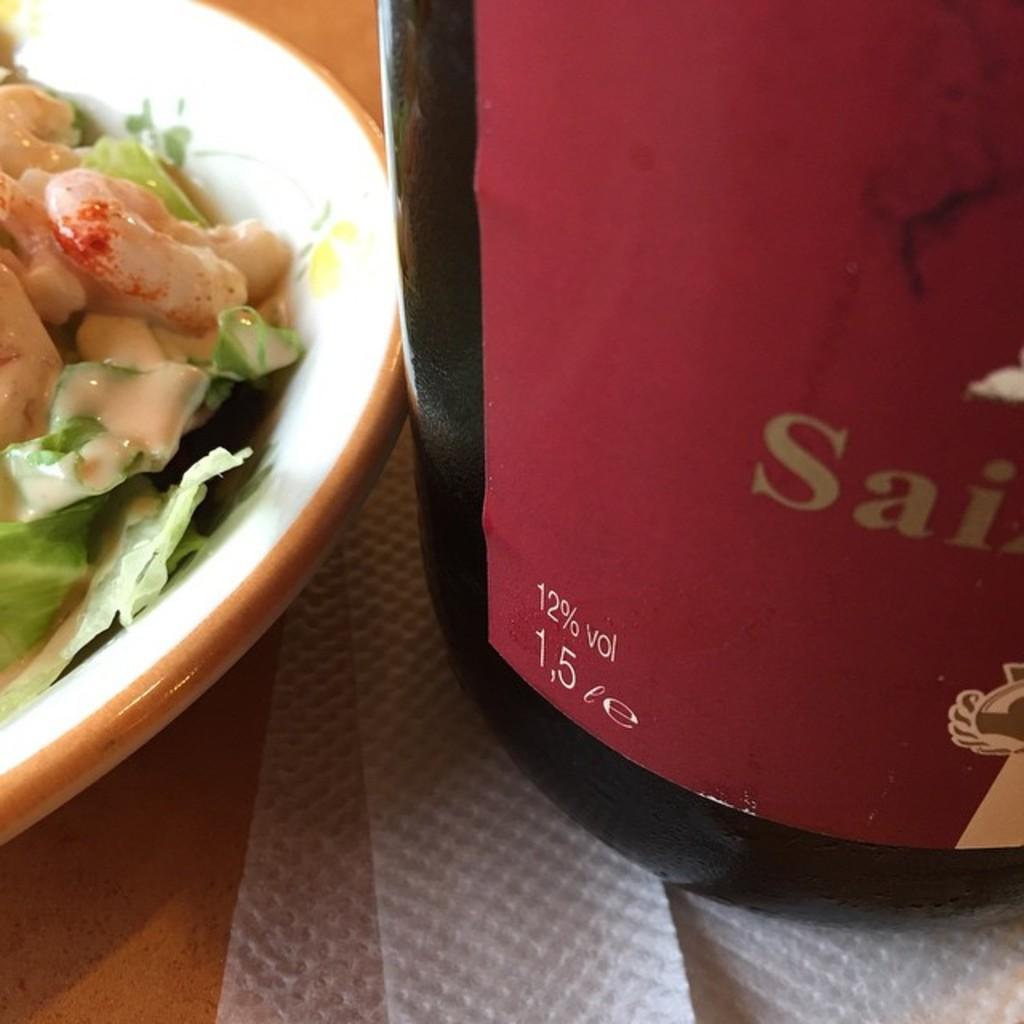How would you summarize this image in a sentence or two? In the image there is a food item served in a bowl and beside the bowl there is a bottle kept on the tissues. 